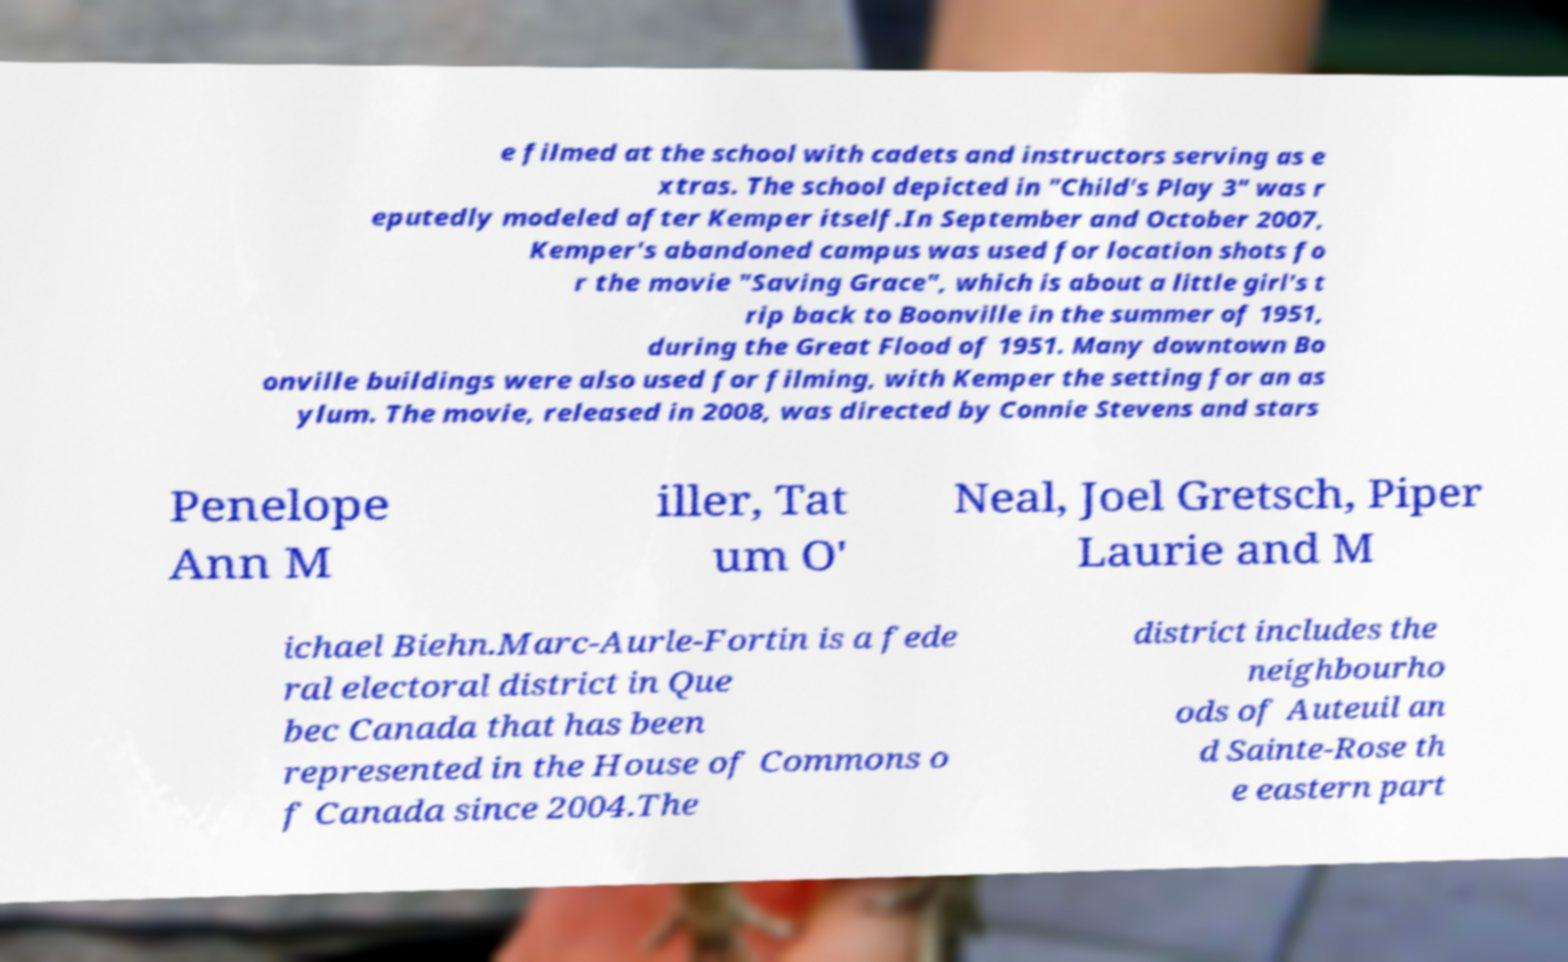I need the written content from this picture converted into text. Can you do that? e filmed at the school with cadets and instructors serving as e xtras. The school depicted in "Child's Play 3" was r eputedly modeled after Kemper itself.In September and October 2007, Kemper's abandoned campus was used for location shots fo r the movie "Saving Grace", which is about a little girl's t rip back to Boonville in the summer of 1951, during the Great Flood of 1951. Many downtown Bo onville buildings were also used for filming, with Kemper the setting for an as ylum. The movie, released in 2008, was directed by Connie Stevens and stars Penelope Ann M iller, Tat um O' Neal, Joel Gretsch, Piper Laurie and M ichael Biehn.Marc-Aurle-Fortin is a fede ral electoral district in Que bec Canada that has been represented in the House of Commons o f Canada since 2004.The district includes the neighbourho ods of Auteuil an d Sainte-Rose th e eastern part 